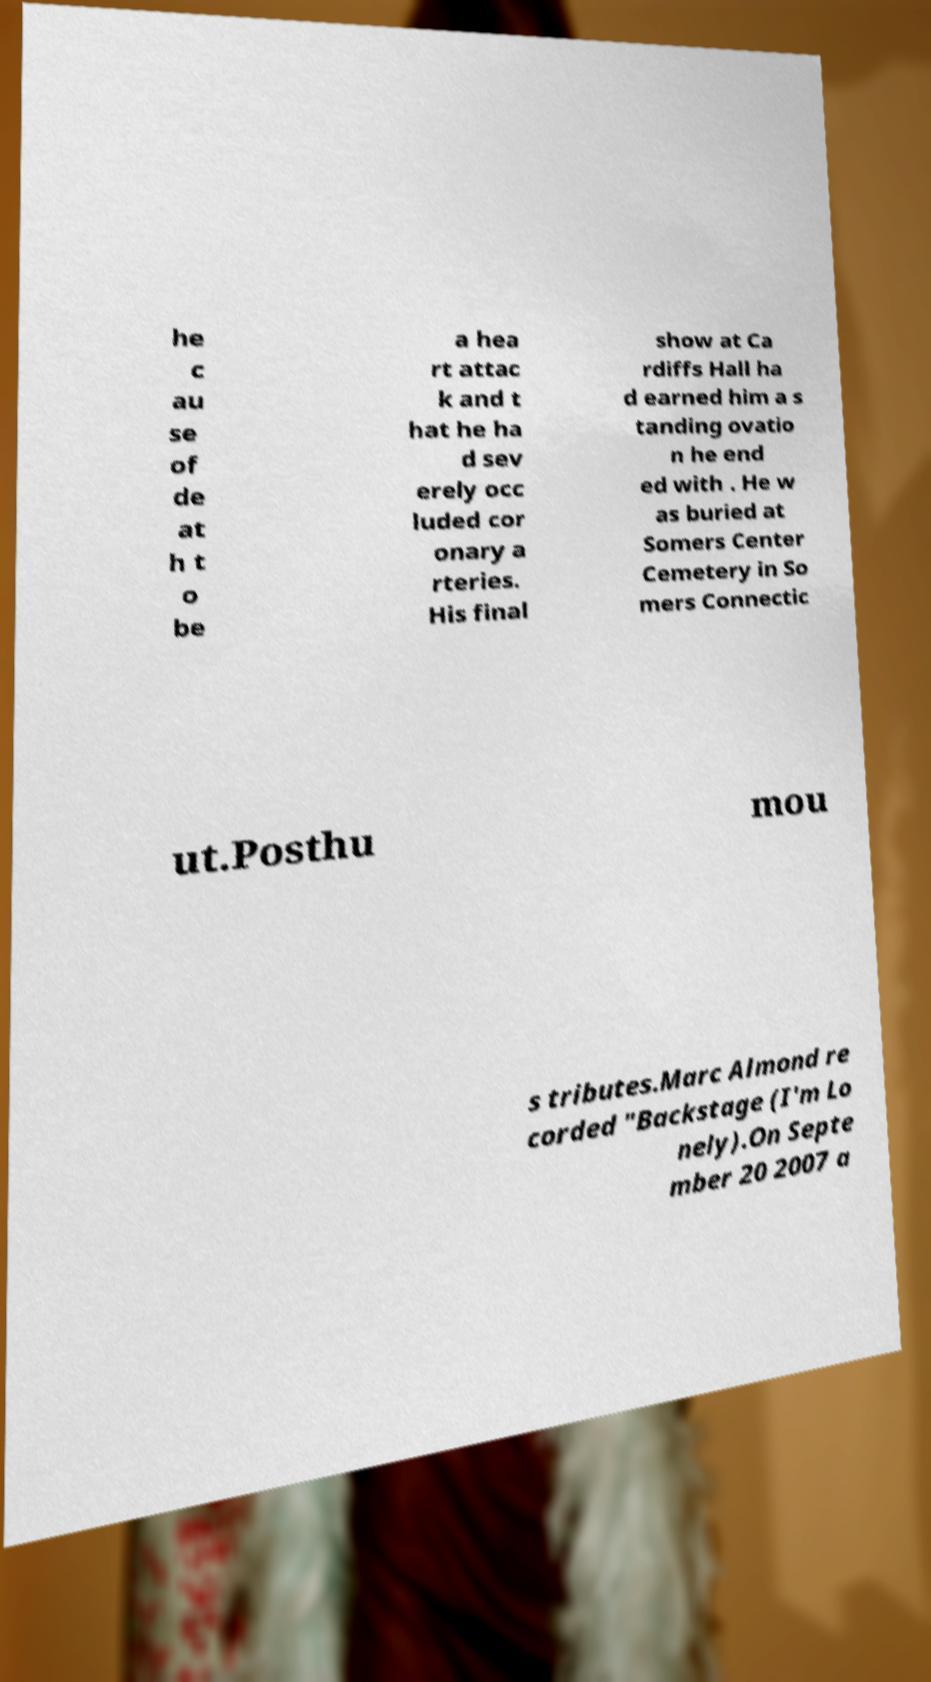There's text embedded in this image that I need extracted. Can you transcribe it verbatim? he c au se of de at h t o be a hea rt attac k and t hat he ha d sev erely occ luded cor onary a rteries. His final show at Ca rdiffs Hall ha d earned him a s tanding ovatio n he end ed with . He w as buried at Somers Center Cemetery in So mers Connectic ut.Posthu mou s tributes.Marc Almond re corded "Backstage (I'm Lo nely).On Septe mber 20 2007 a 